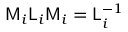Convert formula to latex. <formula><loc_0><loc_0><loc_500><loc_500>M _ { i } L _ { i } M _ { i } = L _ { i } ^ { - 1 }</formula> 